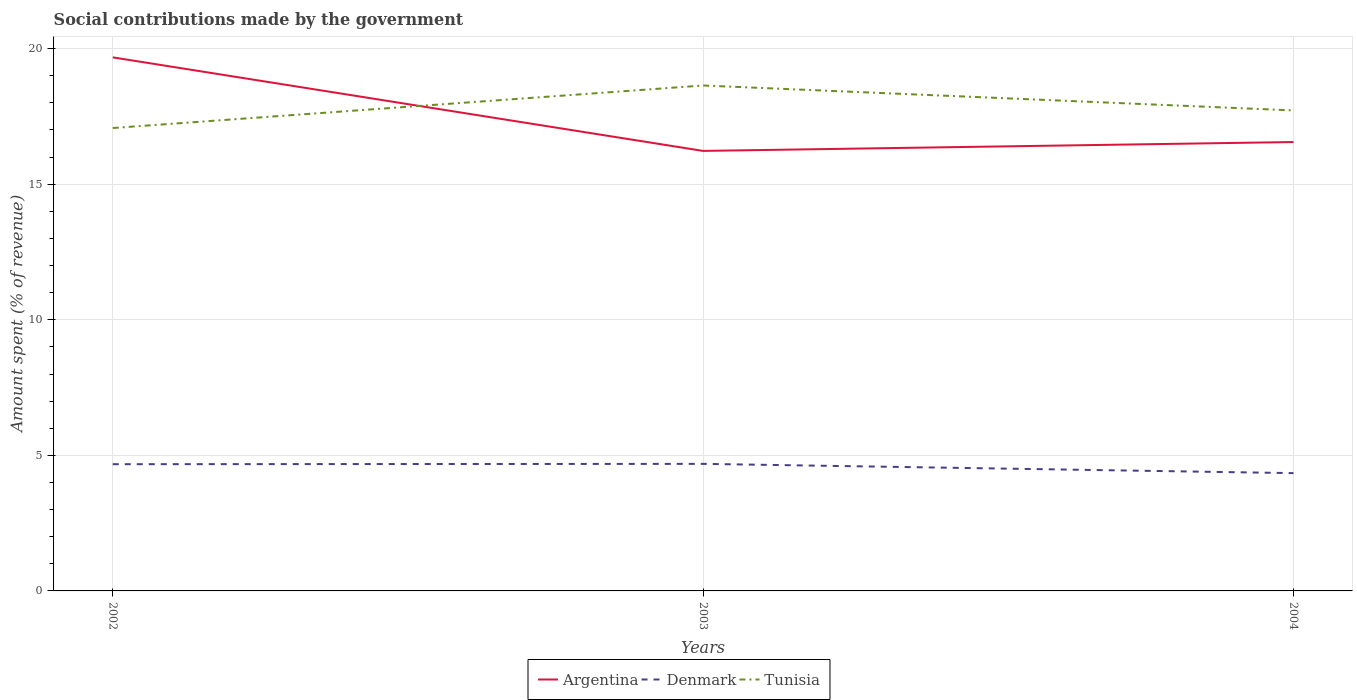How many different coloured lines are there?
Offer a very short reply. 3. Does the line corresponding to Argentina intersect with the line corresponding to Tunisia?
Ensure brevity in your answer.  Yes. Across all years, what is the maximum amount spent (in %) on social contributions in Argentina?
Your response must be concise. 16.23. In which year was the amount spent (in %) on social contributions in Tunisia maximum?
Keep it short and to the point. 2002. What is the total amount spent (in %) on social contributions in Denmark in the graph?
Offer a very short reply. 0.33. What is the difference between the highest and the second highest amount spent (in %) on social contributions in Argentina?
Your answer should be compact. 3.45. What is the difference between the highest and the lowest amount spent (in %) on social contributions in Denmark?
Keep it short and to the point. 2. How many lines are there?
Make the answer very short. 3. How many years are there in the graph?
Your answer should be compact. 3. Does the graph contain any zero values?
Make the answer very short. No. Does the graph contain grids?
Offer a terse response. Yes. How are the legend labels stacked?
Keep it short and to the point. Horizontal. What is the title of the graph?
Make the answer very short. Social contributions made by the government. What is the label or title of the X-axis?
Offer a terse response. Years. What is the label or title of the Y-axis?
Your answer should be very brief. Amount spent (% of revenue). What is the Amount spent (% of revenue) in Argentina in 2002?
Provide a short and direct response. 19.68. What is the Amount spent (% of revenue) of Denmark in 2002?
Give a very brief answer. 4.67. What is the Amount spent (% of revenue) of Tunisia in 2002?
Your response must be concise. 17.07. What is the Amount spent (% of revenue) of Argentina in 2003?
Your answer should be compact. 16.23. What is the Amount spent (% of revenue) of Denmark in 2003?
Make the answer very short. 4.69. What is the Amount spent (% of revenue) of Tunisia in 2003?
Keep it short and to the point. 18.64. What is the Amount spent (% of revenue) of Argentina in 2004?
Offer a very short reply. 16.56. What is the Amount spent (% of revenue) in Denmark in 2004?
Your response must be concise. 4.34. What is the Amount spent (% of revenue) in Tunisia in 2004?
Keep it short and to the point. 17.72. Across all years, what is the maximum Amount spent (% of revenue) in Argentina?
Give a very brief answer. 19.68. Across all years, what is the maximum Amount spent (% of revenue) of Denmark?
Offer a very short reply. 4.69. Across all years, what is the maximum Amount spent (% of revenue) of Tunisia?
Give a very brief answer. 18.64. Across all years, what is the minimum Amount spent (% of revenue) in Argentina?
Provide a short and direct response. 16.23. Across all years, what is the minimum Amount spent (% of revenue) of Denmark?
Your answer should be very brief. 4.34. Across all years, what is the minimum Amount spent (% of revenue) in Tunisia?
Offer a terse response. 17.07. What is the total Amount spent (% of revenue) in Argentina in the graph?
Your response must be concise. 52.46. What is the total Amount spent (% of revenue) in Denmark in the graph?
Provide a succinct answer. 13.7. What is the total Amount spent (% of revenue) of Tunisia in the graph?
Provide a succinct answer. 53.43. What is the difference between the Amount spent (% of revenue) of Argentina in 2002 and that in 2003?
Your response must be concise. 3.45. What is the difference between the Amount spent (% of revenue) in Denmark in 2002 and that in 2003?
Your answer should be very brief. -0.01. What is the difference between the Amount spent (% of revenue) in Tunisia in 2002 and that in 2003?
Offer a terse response. -1.57. What is the difference between the Amount spent (% of revenue) of Argentina in 2002 and that in 2004?
Make the answer very short. 3.12. What is the difference between the Amount spent (% of revenue) of Denmark in 2002 and that in 2004?
Give a very brief answer. 0.33. What is the difference between the Amount spent (% of revenue) of Tunisia in 2002 and that in 2004?
Offer a very short reply. -0.65. What is the difference between the Amount spent (% of revenue) in Argentina in 2003 and that in 2004?
Your answer should be very brief. -0.33. What is the difference between the Amount spent (% of revenue) of Denmark in 2003 and that in 2004?
Keep it short and to the point. 0.34. What is the difference between the Amount spent (% of revenue) of Tunisia in 2003 and that in 2004?
Make the answer very short. 0.92. What is the difference between the Amount spent (% of revenue) in Argentina in 2002 and the Amount spent (% of revenue) in Denmark in 2003?
Offer a terse response. 14.99. What is the difference between the Amount spent (% of revenue) of Argentina in 2002 and the Amount spent (% of revenue) of Tunisia in 2003?
Your response must be concise. 1.04. What is the difference between the Amount spent (% of revenue) in Denmark in 2002 and the Amount spent (% of revenue) in Tunisia in 2003?
Your answer should be compact. -13.97. What is the difference between the Amount spent (% of revenue) in Argentina in 2002 and the Amount spent (% of revenue) in Denmark in 2004?
Offer a terse response. 15.33. What is the difference between the Amount spent (% of revenue) in Argentina in 2002 and the Amount spent (% of revenue) in Tunisia in 2004?
Your answer should be compact. 1.96. What is the difference between the Amount spent (% of revenue) of Denmark in 2002 and the Amount spent (% of revenue) of Tunisia in 2004?
Make the answer very short. -13.05. What is the difference between the Amount spent (% of revenue) in Argentina in 2003 and the Amount spent (% of revenue) in Denmark in 2004?
Your response must be concise. 11.88. What is the difference between the Amount spent (% of revenue) in Argentina in 2003 and the Amount spent (% of revenue) in Tunisia in 2004?
Make the answer very short. -1.49. What is the difference between the Amount spent (% of revenue) in Denmark in 2003 and the Amount spent (% of revenue) in Tunisia in 2004?
Provide a short and direct response. -13.04. What is the average Amount spent (% of revenue) in Argentina per year?
Your response must be concise. 17.49. What is the average Amount spent (% of revenue) in Denmark per year?
Your response must be concise. 4.57. What is the average Amount spent (% of revenue) of Tunisia per year?
Offer a terse response. 17.81. In the year 2002, what is the difference between the Amount spent (% of revenue) of Argentina and Amount spent (% of revenue) of Denmark?
Give a very brief answer. 15. In the year 2002, what is the difference between the Amount spent (% of revenue) in Argentina and Amount spent (% of revenue) in Tunisia?
Provide a short and direct response. 2.61. In the year 2002, what is the difference between the Amount spent (% of revenue) of Denmark and Amount spent (% of revenue) of Tunisia?
Offer a very short reply. -12.4. In the year 2003, what is the difference between the Amount spent (% of revenue) in Argentina and Amount spent (% of revenue) in Denmark?
Keep it short and to the point. 11.54. In the year 2003, what is the difference between the Amount spent (% of revenue) of Argentina and Amount spent (% of revenue) of Tunisia?
Offer a terse response. -2.41. In the year 2003, what is the difference between the Amount spent (% of revenue) in Denmark and Amount spent (% of revenue) in Tunisia?
Your answer should be very brief. -13.96. In the year 2004, what is the difference between the Amount spent (% of revenue) of Argentina and Amount spent (% of revenue) of Denmark?
Your response must be concise. 12.21. In the year 2004, what is the difference between the Amount spent (% of revenue) in Argentina and Amount spent (% of revenue) in Tunisia?
Your answer should be compact. -1.17. In the year 2004, what is the difference between the Amount spent (% of revenue) in Denmark and Amount spent (% of revenue) in Tunisia?
Give a very brief answer. -13.38. What is the ratio of the Amount spent (% of revenue) of Argentina in 2002 to that in 2003?
Make the answer very short. 1.21. What is the ratio of the Amount spent (% of revenue) of Tunisia in 2002 to that in 2003?
Make the answer very short. 0.92. What is the ratio of the Amount spent (% of revenue) of Argentina in 2002 to that in 2004?
Your answer should be very brief. 1.19. What is the ratio of the Amount spent (% of revenue) in Denmark in 2002 to that in 2004?
Give a very brief answer. 1.08. What is the ratio of the Amount spent (% of revenue) of Tunisia in 2002 to that in 2004?
Your answer should be very brief. 0.96. What is the ratio of the Amount spent (% of revenue) of Argentina in 2003 to that in 2004?
Keep it short and to the point. 0.98. What is the ratio of the Amount spent (% of revenue) of Denmark in 2003 to that in 2004?
Provide a short and direct response. 1.08. What is the ratio of the Amount spent (% of revenue) of Tunisia in 2003 to that in 2004?
Your answer should be very brief. 1.05. What is the difference between the highest and the second highest Amount spent (% of revenue) in Argentina?
Ensure brevity in your answer.  3.12. What is the difference between the highest and the second highest Amount spent (% of revenue) of Denmark?
Provide a succinct answer. 0.01. What is the difference between the highest and the second highest Amount spent (% of revenue) of Tunisia?
Offer a very short reply. 0.92. What is the difference between the highest and the lowest Amount spent (% of revenue) in Argentina?
Your response must be concise. 3.45. What is the difference between the highest and the lowest Amount spent (% of revenue) of Denmark?
Make the answer very short. 0.34. What is the difference between the highest and the lowest Amount spent (% of revenue) of Tunisia?
Ensure brevity in your answer.  1.57. 